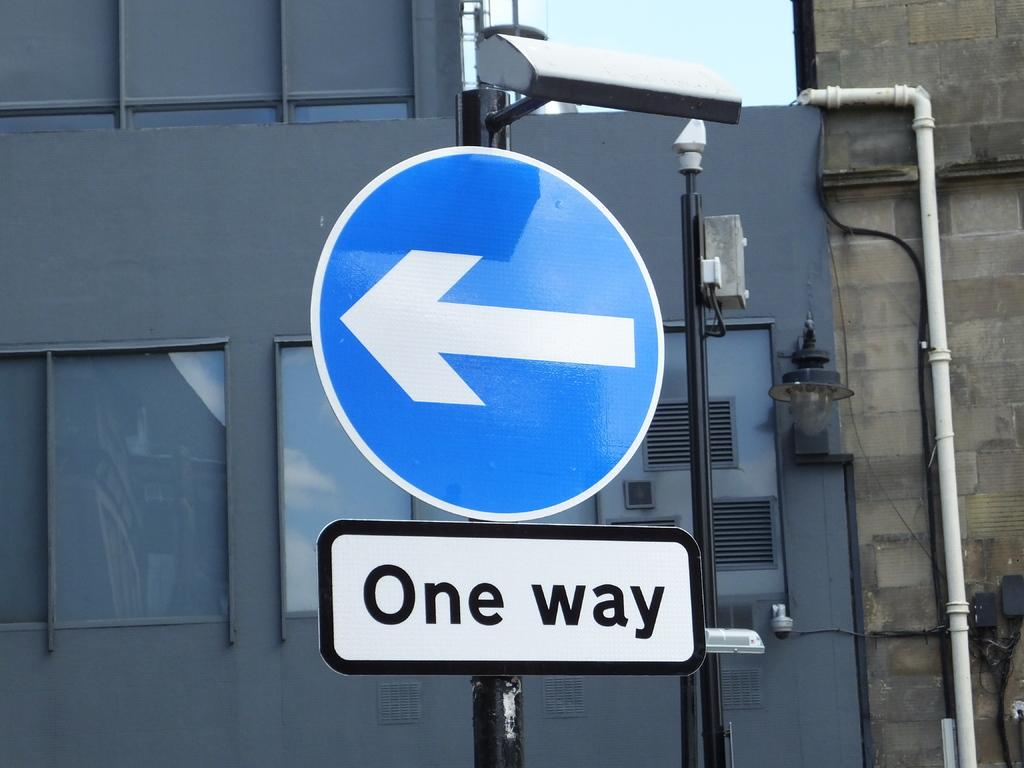Provide a one-sentence caption for the provided image. A blue sign with a white arrow pointing left is labeled One way. 